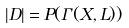<formula> <loc_0><loc_0><loc_500><loc_500>| D | = P ( \Gamma ( X , L ) )</formula> 